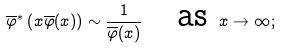<formula> <loc_0><loc_0><loc_500><loc_500>\overline { \varphi } ^ { * } \left ( x \overline { \varphi } ( x ) \right ) \sim \frac { 1 } { \overline { \varphi } ( x ) } \quad \text {as } x \to \infty ;</formula> 